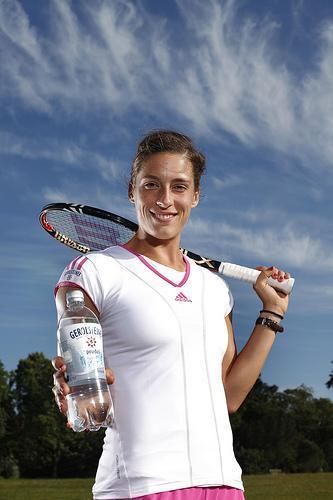How many people are in the photo?
Give a very brief answer. 1. 